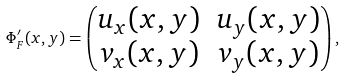<formula> <loc_0><loc_0><loc_500><loc_500>\Phi ^ { \prime } _ { F } ( x , y ) = \begin{pmatrix} u _ { x } ( x , y ) & u _ { y } ( x , y ) \\ v _ { x } ( x , y ) & v _ { y } ( x , y ) \end{pmatrix} ,</formula> 